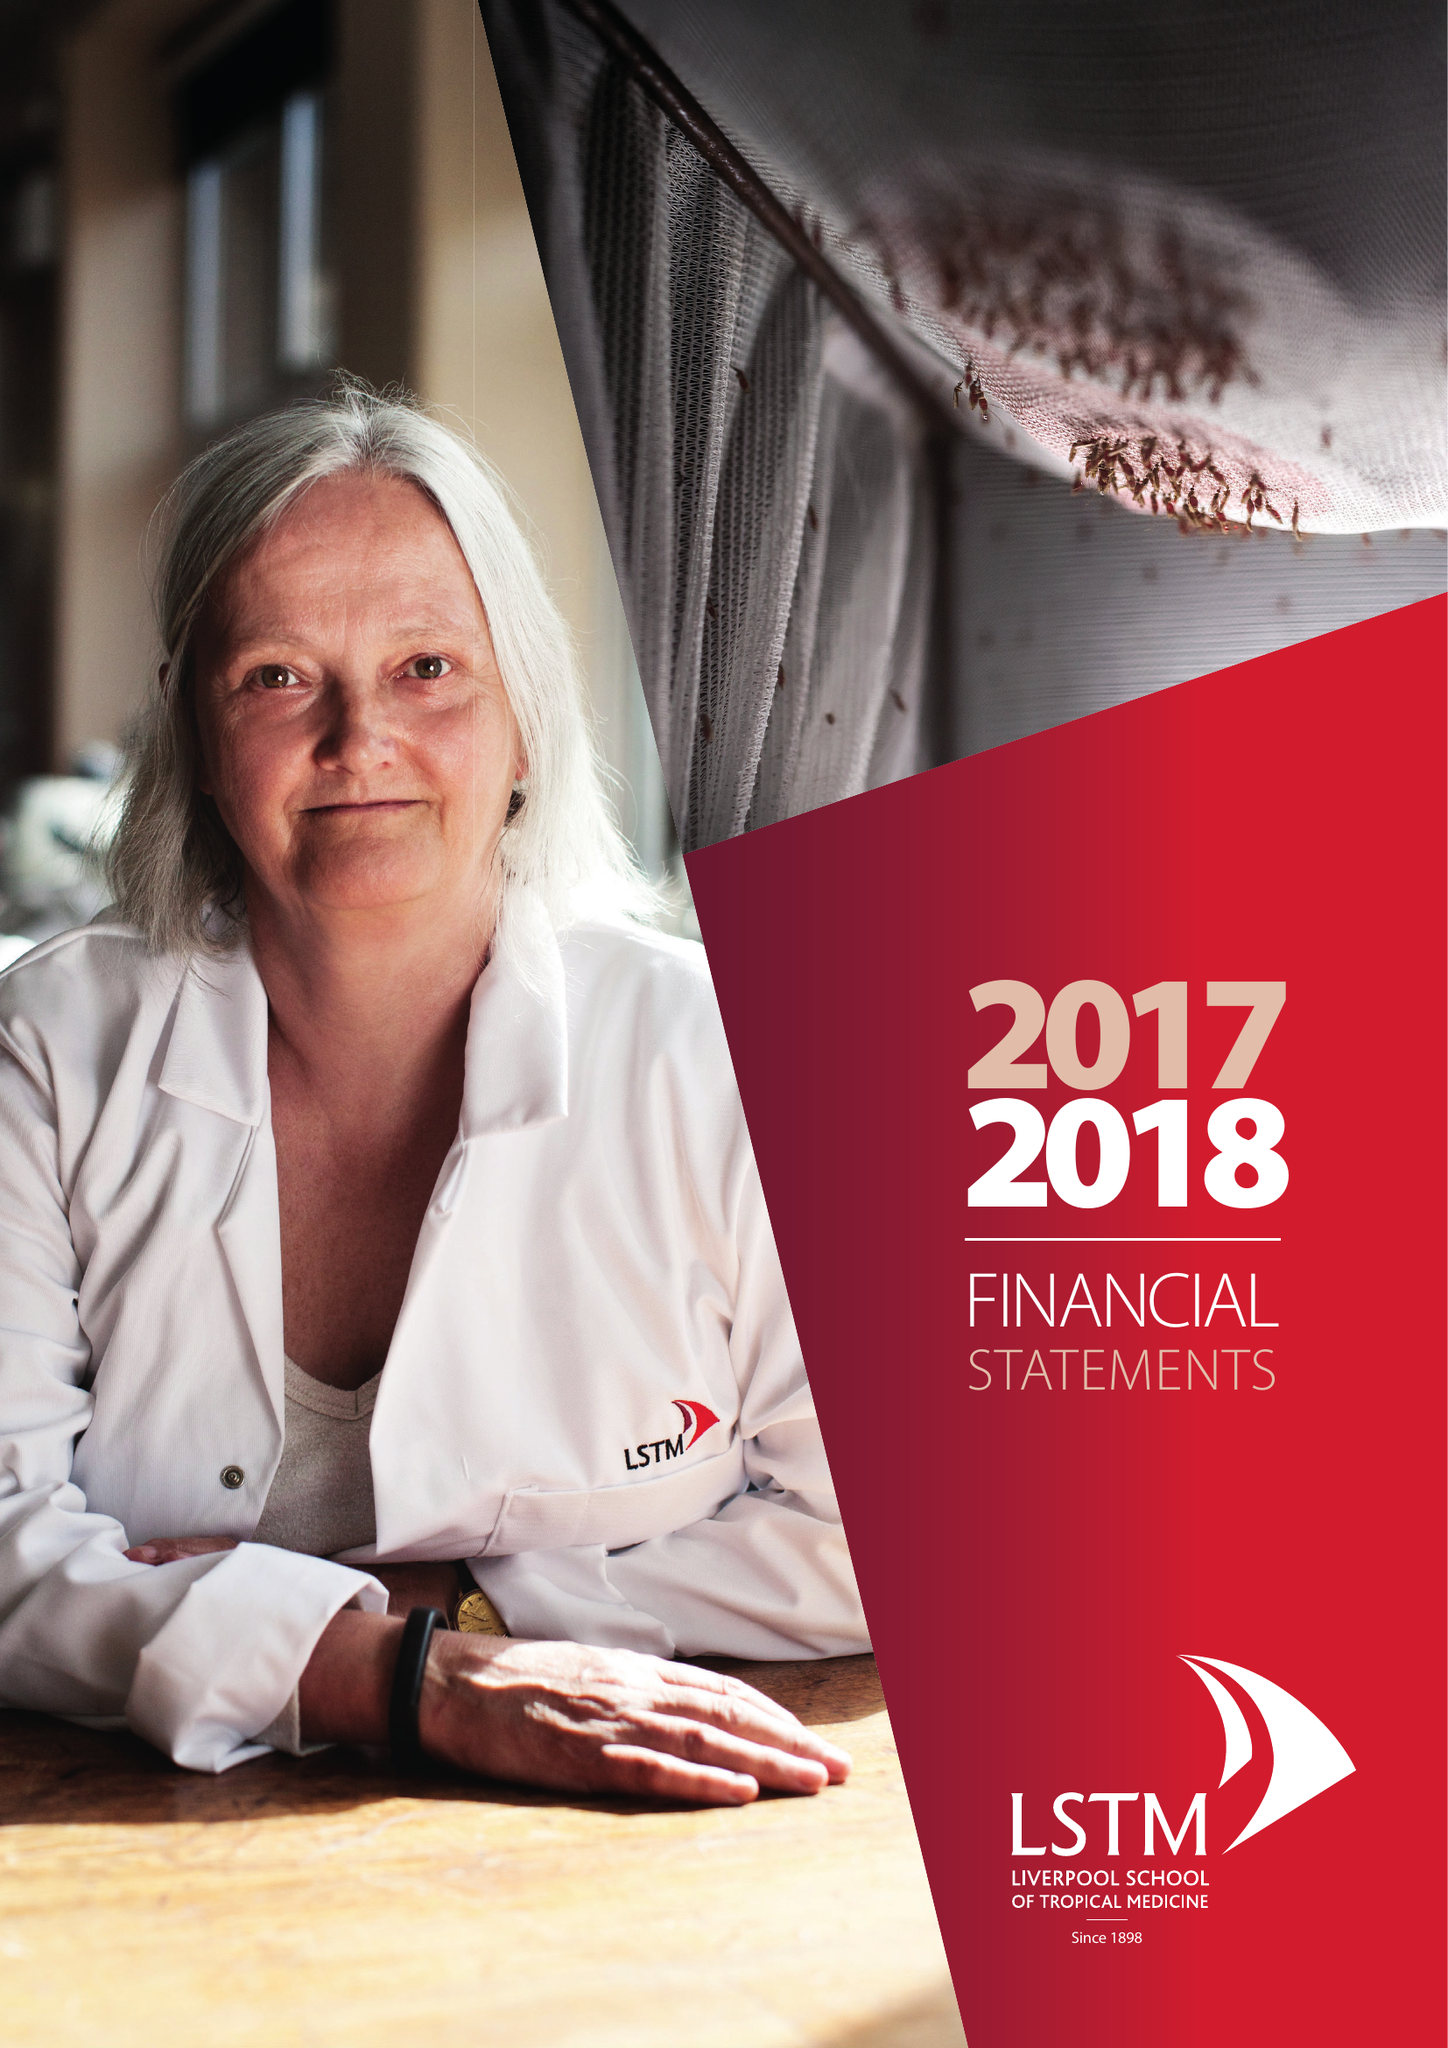What is the value for the charity_name?
Answer the question using a single word or phrase. Liverpool School Of Tropical Medicine 